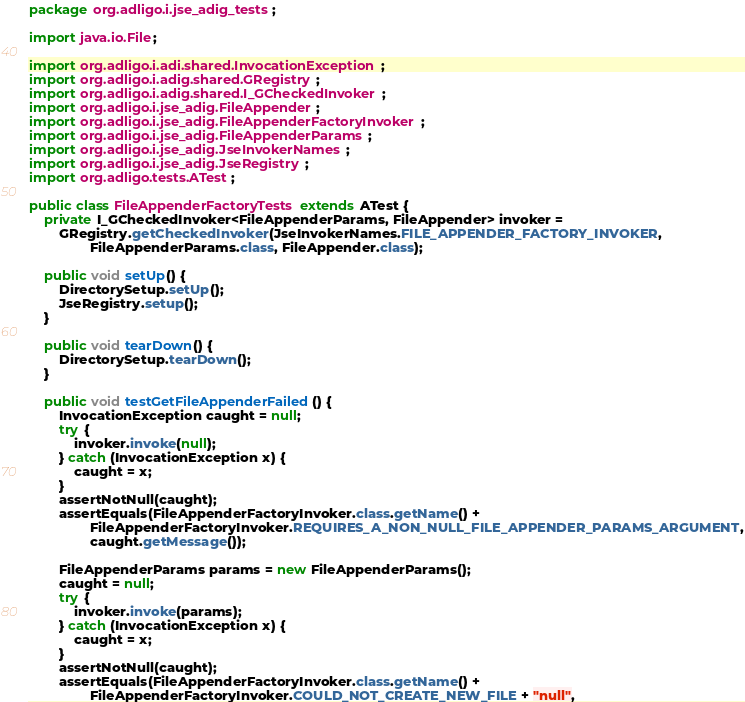Convert code to text. <code><loc_0><loc_0><loc_500><loc_500><_Java_>package org.adligo.i.jse_adig_tests;

import java.io.File;

import org.adligo.i.adi.shared.InvocationException;
import org.adligo.i.adig.shared.GRegistry;
import org.adligo.i.adig.shared.I_GCheckedInvoker;
import org.adligo.i.jse_adig.FileAppender;
import org.adligo.i.jse_adig.FileAppenderFactoryInvoker;
import org.adligo.i.jse_adig.FileAppenderParams;
import org.adligo.i.jse_adig.JseInvokerNames;
import org.adligo.i.jse_adig.JseRegistry;
import org.adligo.tests.ATest;

public class FileAppenderFactoryTests extends ATest {
	private I_GCheckedInvoker<FileAppenderParams, FileAppender> invoker = 
		GRegistry.getCheckedInvoker(JseInvokerNames.FILE_APPENDER_FACTORY_INVOKER, 
				FileAppenderParams.class, FileAppender.class);
	
	public void setUp() {
		DirectorySetup.setUp();
		JseRegistry.setup();
	}
	
	public void tearDown() {
		DirectorySetup.tearDown();
	}
	
	public void testGetFileAppenderFailed() {
		InvocationException caught = null;
		try {
			invoker.invoke(null);
		} catch (InvocationException x) {
			caught = x;
		}
		assertNotNull(caught);
		assertEquals(FileAppenderFactoryInvoker.class.getName() + 
				FileAppenderFactoryInvoker.REQUIRES_A_NON_NULL_FILE_APPENDER_PARAMS_ARGUMENT,
				caught.getMessage());
		
		FileAppenderParams params = new FileAppenderParams();
		caught = null;
		try {
			invoker.invoke(params);
		} catch (InvocationException x) {
			caught = x;
		}
		assertNotNull(caught);
		assertEquals(FileAppenderFactoryInvoker.class.getName() + 
				FileAppenderFactoryInvoker.COULD_NOT_CREATE_NEW_FILE + "null",</code> 